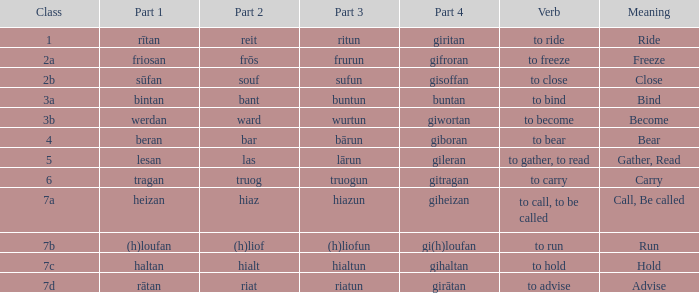What is the verb meaning of the word with part 3 "sufun"? To close. 